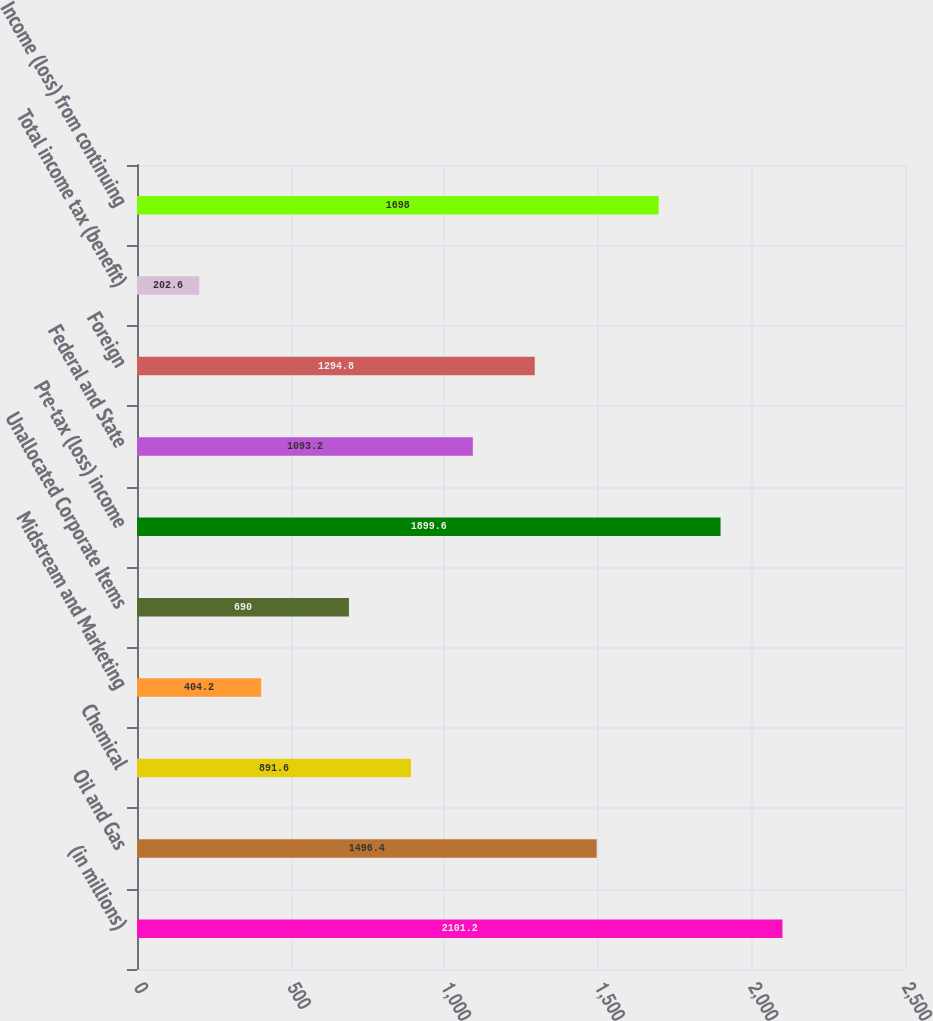<chart> <loc_0><loc_0><loc_500><loc_500><bar_chart><fcel>(in millions)<fcel>Oil and Gas<fcel>Chemical<fcel>Midstream and Marketing<fcel>Unallocated Corporate Items<fcel>Pre-tax (loss) income<fcel>Federal and State<fcel>Foreign<fcel>Total income tax (benefit)<fcel>Income (loss) from continuing<nl><fcel>2101.2<fcel>1496.4<fcel>891.6<fcel>404.2<fcel>690<fcel>1899.6<fcel>1093.2<fcel>1294.8<fcel>202.6<fcel>1698<nl></chart> 